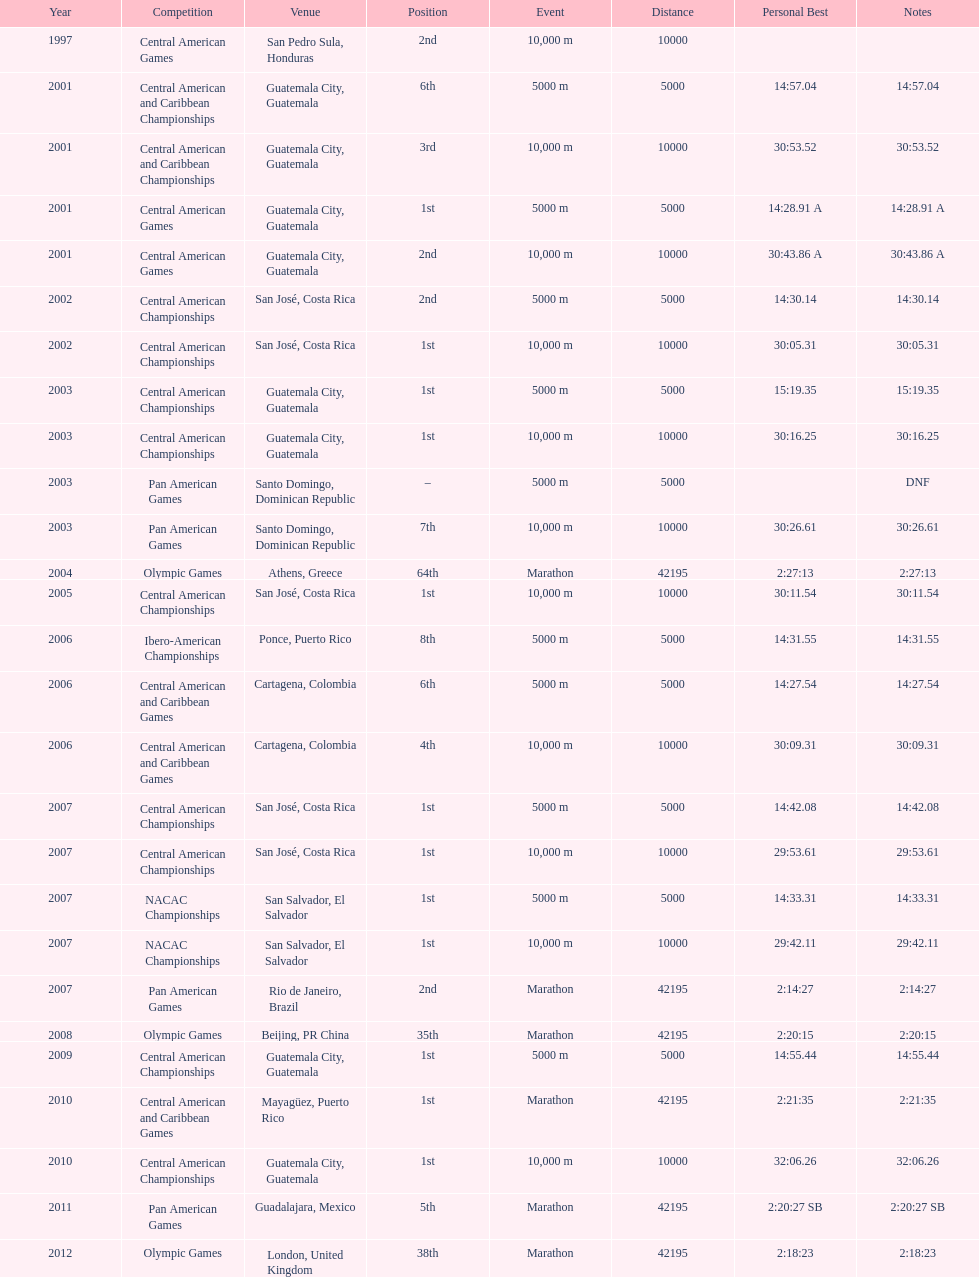How many instances has the rank of 1st been attained? 12. 